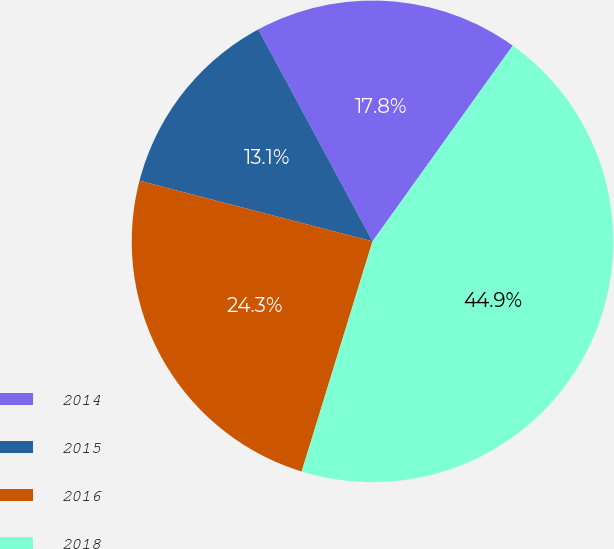Convert chart to OTSL. <chart><loc_0><loc_0><loc_500><loc_500><pie_chart><fcel>2014<fcel>2015<fcel>2016<fcel>2018<nl><fcel>17.76%<fcel>13.08%<fcel>24.3%<fcel>44.86%<nl></chart> 